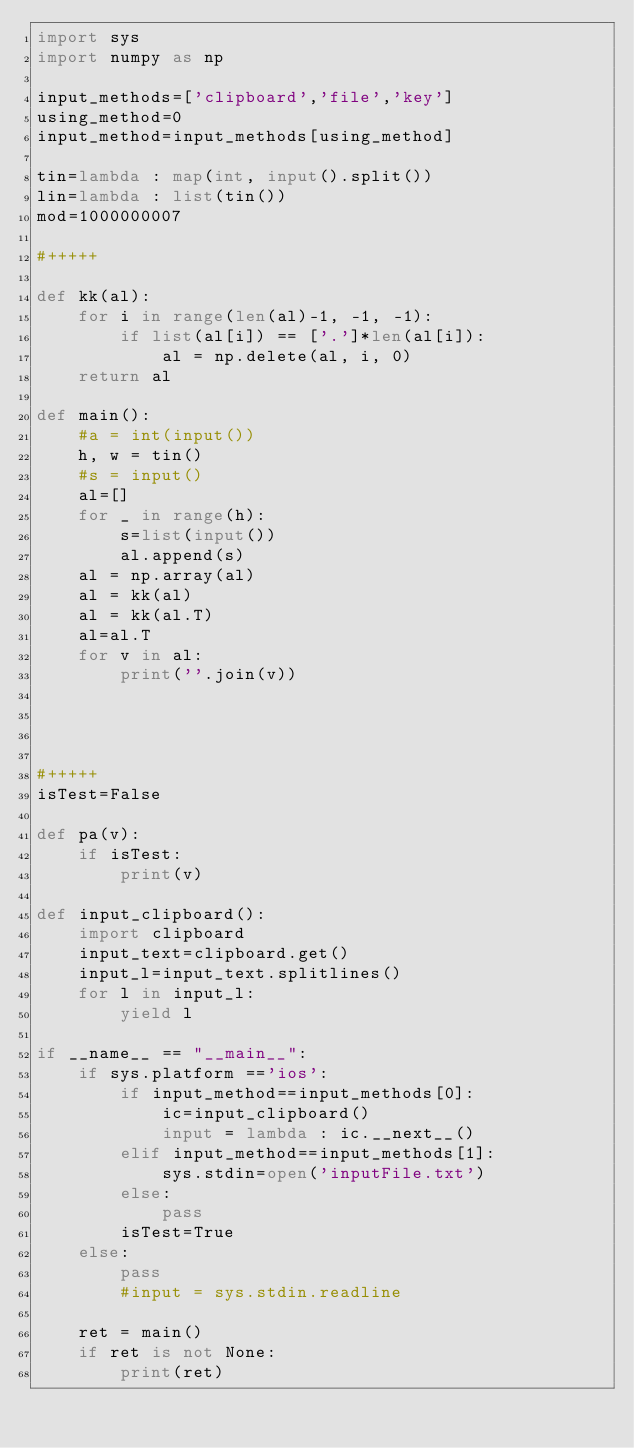<code> <loc_0><loc_0><loc_500><loc_500><_Python_>import sys
import numpy as np

input_methods=['clipboard','file','key']
using_method=0
input_method=input_methods[using_method]

tin=lambda : map(int, input().split())
lin=lambda : list(tin())
mod=1000000007

#+++++

def kk(al):
	for i in range(len(al)-1, -1, -1):
		if list(al[i]) == ['.']*len(al[i]):
			al = np.delete(al, i, 0)
	return al

def main():
	#a = int(input())
	h, w = tin()
	#s = input()
	al=[]
	for _ in range(h):
		s=list(input())
		al.append(s)
	al = np.array(al)
	al = kk(al)
	al = kk(al.T)
	al=al.T
	for v in al:
		print(''.join(v))
		
	
	
	
#+++++
isTest=False

def pa(v):
	if isTest:
		print(v)
		
def input_clipboard():
	import clipboard
	input_text=clipboard.get()
	input_l=input_text.splitlines()
	for l in input_l:
		yield l

if __name__ == "__main__":
	if sys.platform =='ios':
		if input_method==input_methods[0]:
			ic=input_clipboard()
			input = lambda : ic.__next__()
		elif input_method==input_methods[1]:
			sys.stdin=open('inputFile.txt')
		else:
			pass
		isTest=True
	else:
		pass
		#input = sys.stdin.readline
			
	ret = main()
	if ret is not None:
		print(ret)</code> 